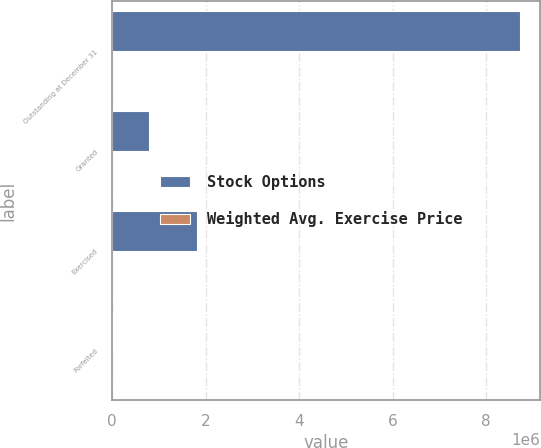Convert chart. <chart><loc_0><loc_0><loc_500><loc_500><stacked_bar_chart><ecel><fcel>Outstanding at December 31<fcel>Granted<fcel>Exercised<fcel>Forfeited<nl><fcel>Stock Options<fcel>8.71857e+06<fcel>777600<fcel>1.80977e+06<fcel>8700<nl><fcel>Weighted Avg. Exercise Price<fcel>47.61<fcel>75.14<fcel>26.95<fcel>57.28<nl></chart> 